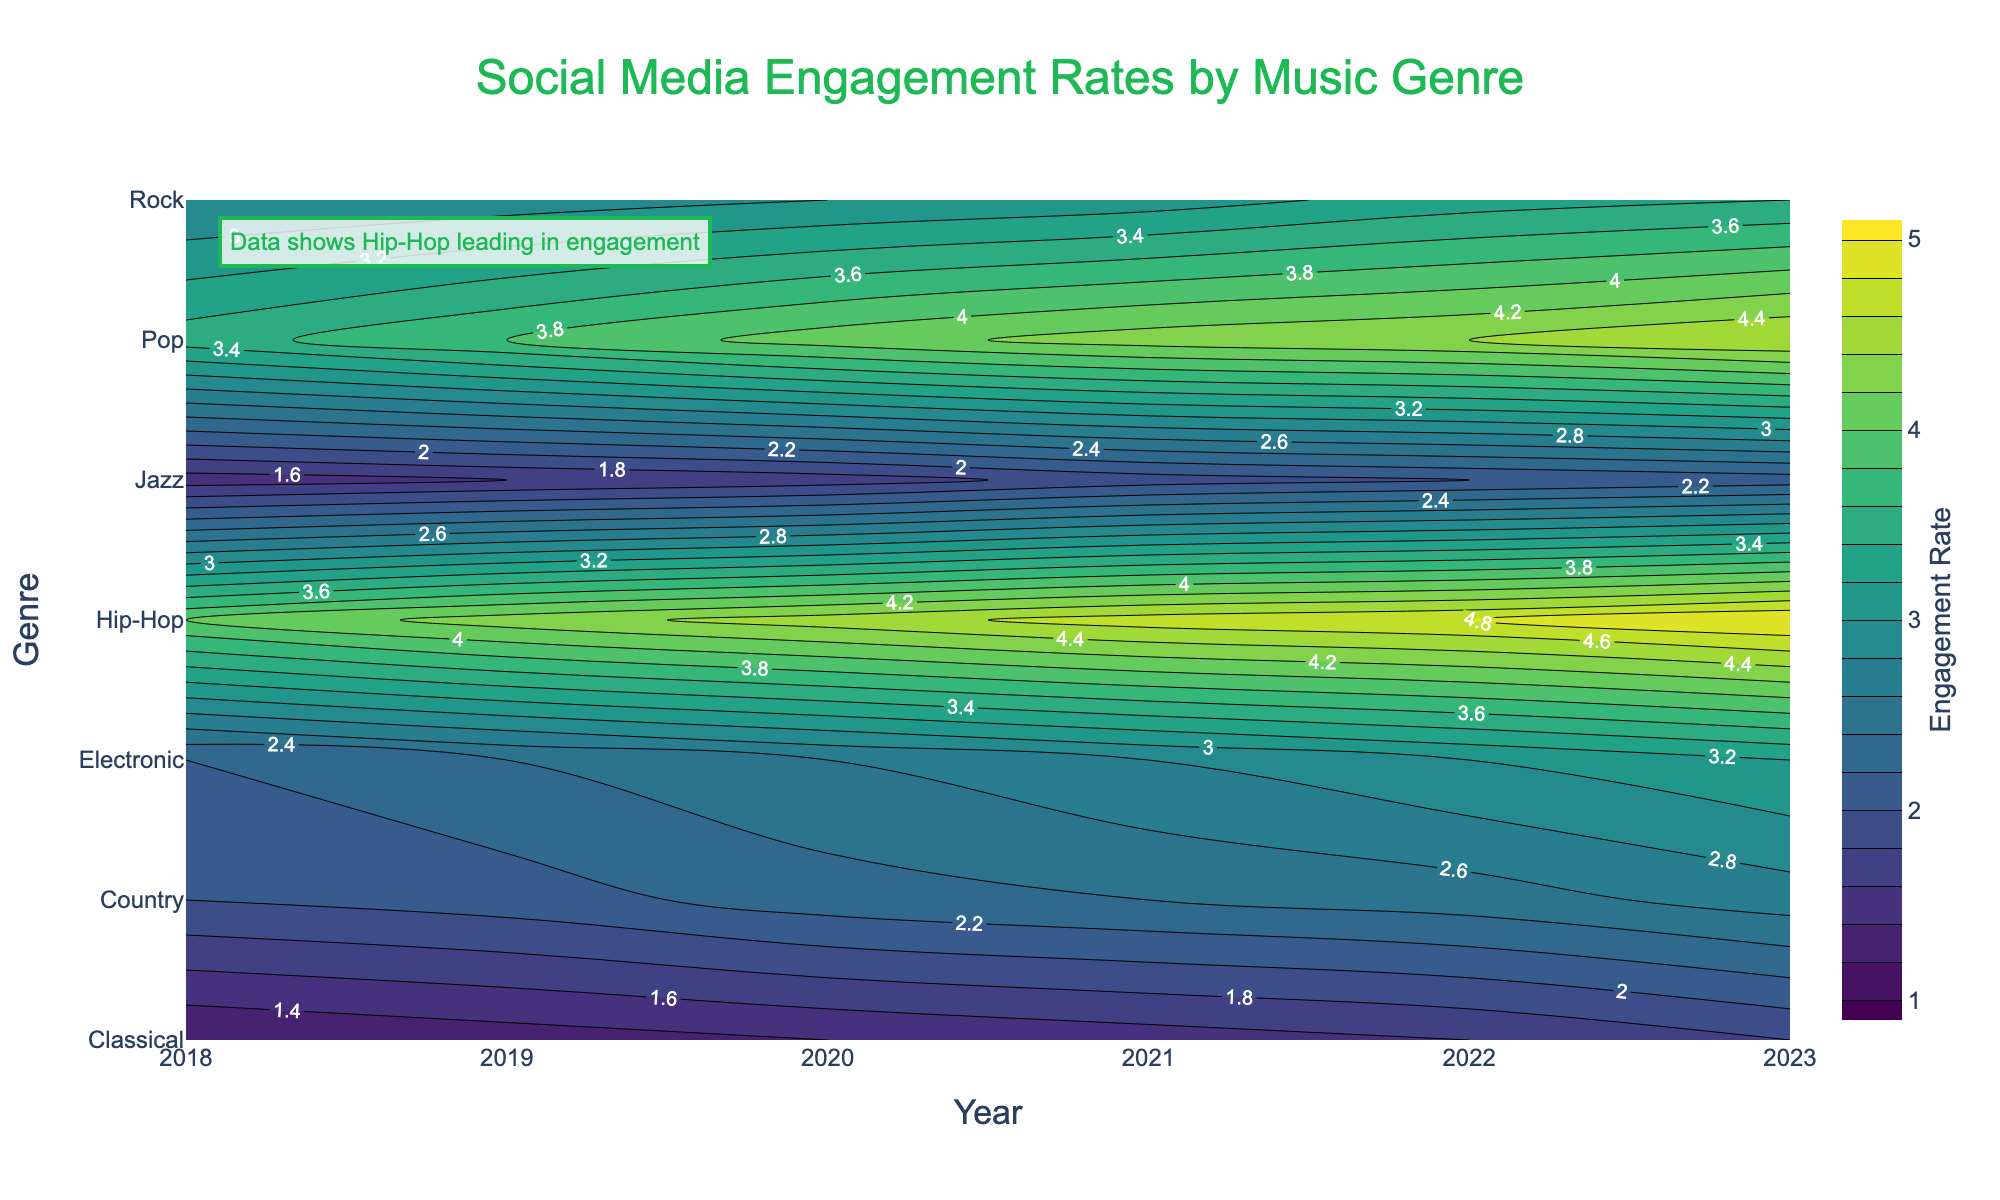What is the title of the figure? The title is usually placed at the top of the figure and typically provides an overview of what the figure displays. Look for large text centered at the top.
Answer: Social Media Engagement Rates by Music Genre Which genre had the highest engagement rate in 2023? Look at the contour lines and labels on the right side of the plot for the year 2023 and identify the genre with the highest rate. In this case, it's the genre with the highest value.
Answer: Hip-Hop What is the average engagement rate for Pop music over the period from 2018 to 2023? Sum the annual engagement rates for Pop music from 2018 to 2023 and then divide by the number of years. Calculation: (3.5 + 3.8 + 4.1 + 4.3 + 4.4 + 4.6) / 6
Answer: 3.95 How does the engagement rate for Jazz in 2023 compare to that for Classical in 2018? Find the engagement rate for Jazz in 2023 and for Classical in 2018 from the contour plot and compare them.
Answer: Jazz in 2023 is higher Which genre showed the most consistent engagement rate increase over the years from 2018 to 2023? Evaluate each genre's engagement rate over the years and determine which one exhibits the most consistent year-over-year increase. Typically, this can be done by looking at smooth and evenly spaced contour lines.
Answer: Hip-Hop Between 2020 and 2023, which genre had the largest increase in engagement rates? Calculate the difference in engagement rates between 2020 and 2023 for each genre and identify the largest increase. Hip-Hop: 5.0 - 4.5 = 0.5, Pop: 4.6 - 4.1 = 0.5, and so on.
Answer: Hip-Hop What is the contour line interval in the plot? Contour intervals are usually detailed in the contours section of the plot settings; find this information and check the increment of the labeled contour lines.
Answer: 0.2 How much did the engagement rate for Country music increase from 2018 to 2023? Subtract the 2018 engagement rate for Country music from its 2023 engagement rate. Calculation: 2.7 - 2.0
Answer: 0.7 What genre has the lowest engagement rate in 2023 according to the plot? Locate the contour lines and labels for the year 2023 and identify the genre with the lowest value.
Answer: Classical How does the growth rate of engagement for Rock music compare to Electronic music from 2018 to 2023? For each genre, calculate the difference in engagement rates between 2018 and 2023 and compare these differences. Rock: 3.4 - 2.8 = 0.6, Electronic: 3.2 - 2.2 = 1.0.
Answer: Electronic had a higher growth rate 